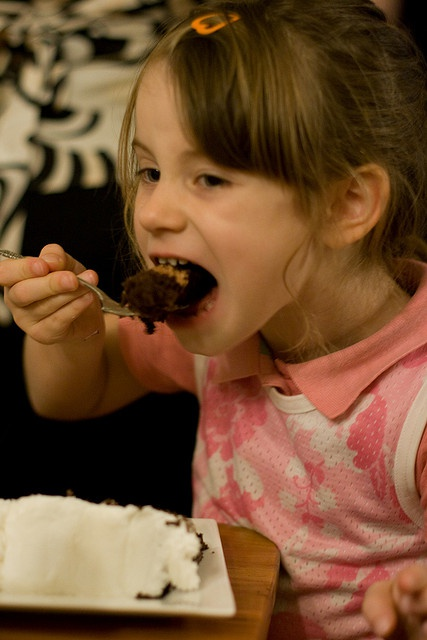Describe the objects in this image and their specific colors. I can see people in black, maroon, salmon, and brown tones, dining table in black, tan, and maroon tones, cake in black and tan tones, and fork in black, olive, and maroon tones in this image. 